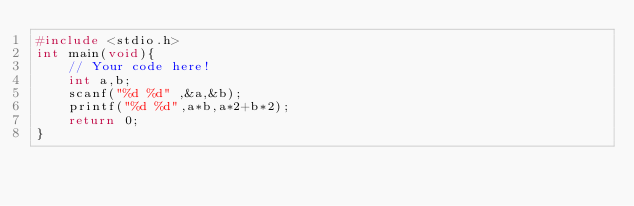Convert code to text. <code><loc_0><loc_0><loc_500><loc_500><_C_>#include <stdio.h>
int main(void){
    // Your code here!
    int a,b;
    scanf("%d %d" ,&a,&b);
    printf("%d %d",a*b,a*2+b*2);
    return 0;
}

</code> 